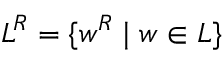Convert formula to latex. <formula><loc_0><loc_0><loc_500><loc_500>L ^ { R } = \{ w ^ { R } | w \in L \}</formula> 